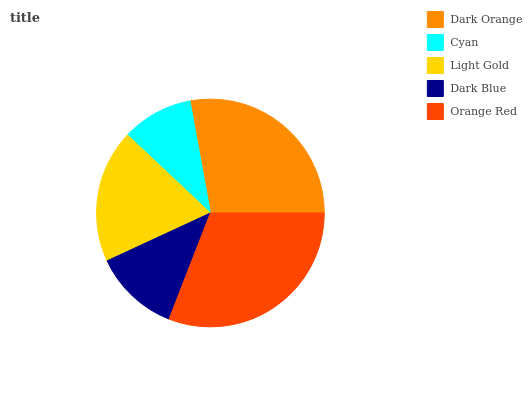Is Cyan the minimum?
Answer yes or no. Yes. Is Orange Red the maximum?
Answer yes or no. Yes. Is Light Gold the minimum?
Answer yes or no. No. Is Light Gold the maximum?
Answer yes or no. No. Is Light Gold greater than Cyan?
Answer yes or no. Yes. Is Cyan less than Light Gold?
Answer yes or no. Yes. Is Cyan greater than Light Gold?
Answer yes or no. No. Is Light Gold less than Cyan?
Answer yes or no. No. Is Light Gold the high median?
Answer yes or no. Yes. Is Light Gold the low median?
Answer yes or no. Yes. Is Dark Orange the high median?
Answer yes or no. No. Is Dark Orange the low median?
Answer yes or no. No. 